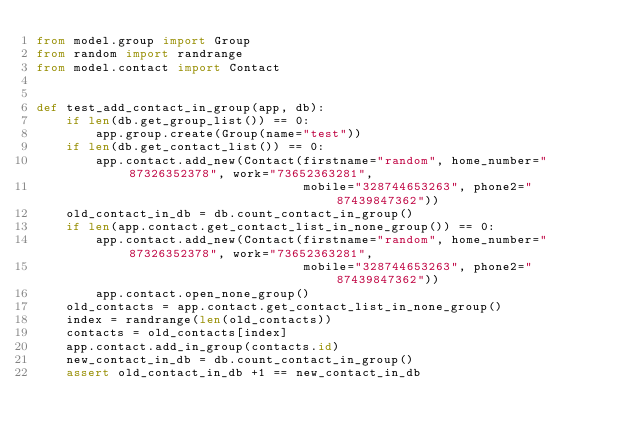<code> <loc_0><loc_0><loc_500><loc_500><_Python_>from model.group import Group
from random import randrange
from model.contact import Contact


def test_add_contact_in_group(app, db):
    if len(db.get_group_list()) == 0:
        app.group.create(Group(name="test"))
    if len(db.get_contact_list()) == 0:
        app.contact.add_new(Contact(firstname="random", home_number="87326352378", work="73652363281",
                                    mobile="328744653263", phone2="87439847362"))
    old_contact_in_db = db.count_contact_in_group()
    if len(app.contact.get_contact_list_in_none_group()) == 0:
        app.contact.add_new(Contact(firstname="random", home_number="87326352378", work="73652363281",
                                    mobile="328744653263", phone2="87439847362"))
        app.contact.open_none_group()
    old_contacts = app.contact.get_contact_list_in_none_group()
    index = randrange(len(old_contacts))
    contacts = old_contacts[index]
    app.contact.add_in_group(contacts.id)
    new_contact_in_db = db.count_contact_in_group()
    assert old_contact_in_db +1 == new_contact_in_db</code> 